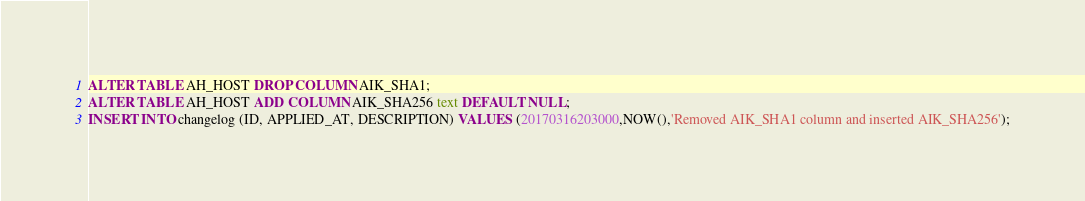Convert code to text. <code><loc_0><loc_0><loc_500><loc_500><_SQL_>

ALTER TABLE AH_HOST DROP COLUMN AIK_SHA1;
ALTER TABLE AH_HOST ADD COLUMN AIK_SHA256 text DEFAULT NULL;
INSERT INTO changelog (ID, APPLIED_AT, DESCRIPTION) VALUES (20170316203000,NOW(),'Removed AIK_SHA1 column and inserted AIK_SHA256');</code> 